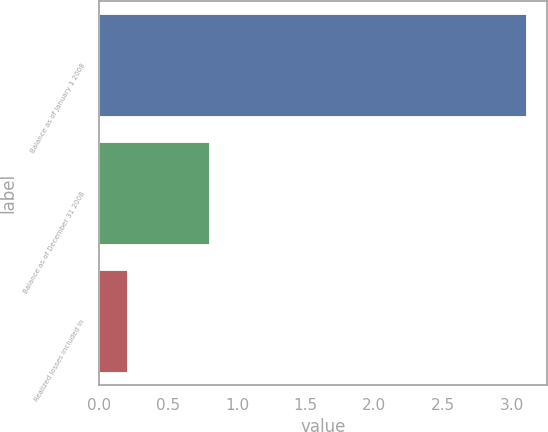Convert chart. <chart><loc_0><loc_0><loc_500><loc_500><bar_chart><fcel>Balance as of January 1 2008<fcel>Balance as of December 31 2008<fcel>Realized losses included in<nl><fcel>3.1<fcel>0.8<fcel>0.2<nl></chart> 